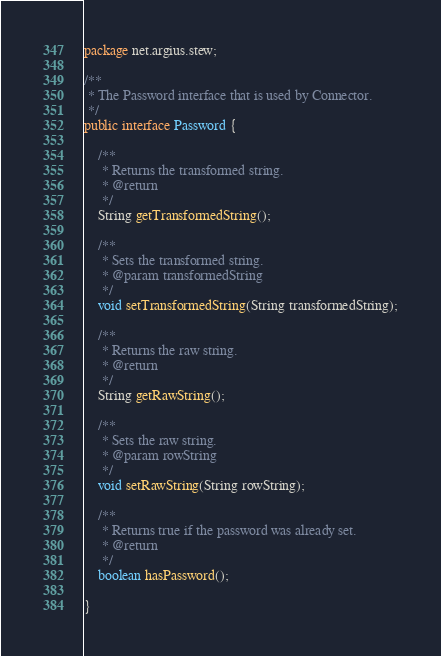Convert code to text. <code><loc_0><loc_0><loc_500><loc_500><_Java_>package net.argius.stew;

/**
 * The Password interface that is used by Connector.
 */
public interface Password {

    /**
     * Returns the transformed string.
     * @return
     */
    String getTransformedString();

    /**
     * Sets the transformed string.
     * @param transformedString
     */
    void setTransformedString(String transformedString);

    /**
     * Returns the raw string.
     * @return
     */
    String getRawString();

    /**
     * Sets the raw string.
     * @param rowString
     */
    void setRawString(String rowString);

    /**
     * Returns true if the password was already set.
     * @return
     */
    boolean hasPassword();

}
</code> 